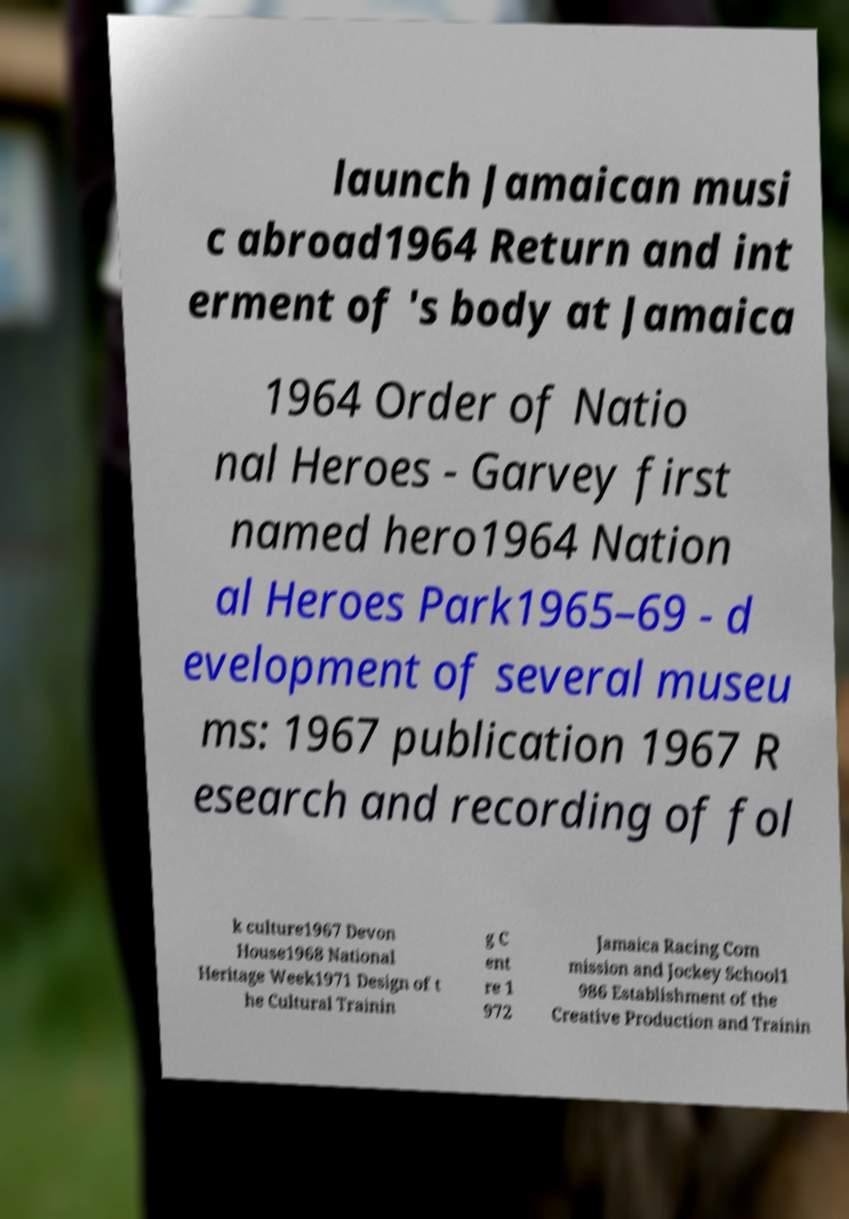For documentation purposes, I need the text within this image transcribed. Could you provide that? launch Jamaican musi c abroad1964 Return and int erment of 's body at Jamaica 1964 Order of Natio nal Heroes - Garvey first named hero1964 Nation al Heroes Park1965–69 - d evelopment of several museu ms: 1967 publication 1967 R esearch and recording of fol k culture1967 Devon House1968 National Heritage Week1971 Design of t he Cultural Trainin g C ent re 1 972 Jamaica Racing Com mission and Jockey School1 986 Establishment of the Creative Production and Trainin 